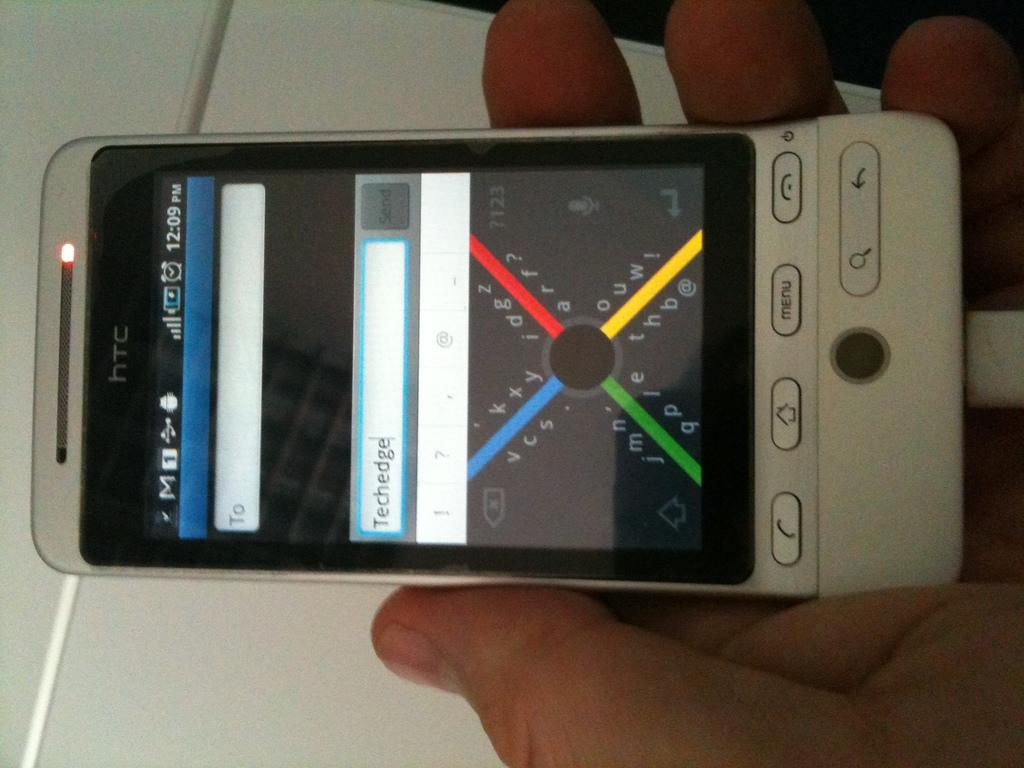<image>
Render a clear and concise summary of the photo. An old style cell phone with htc written on the top. 